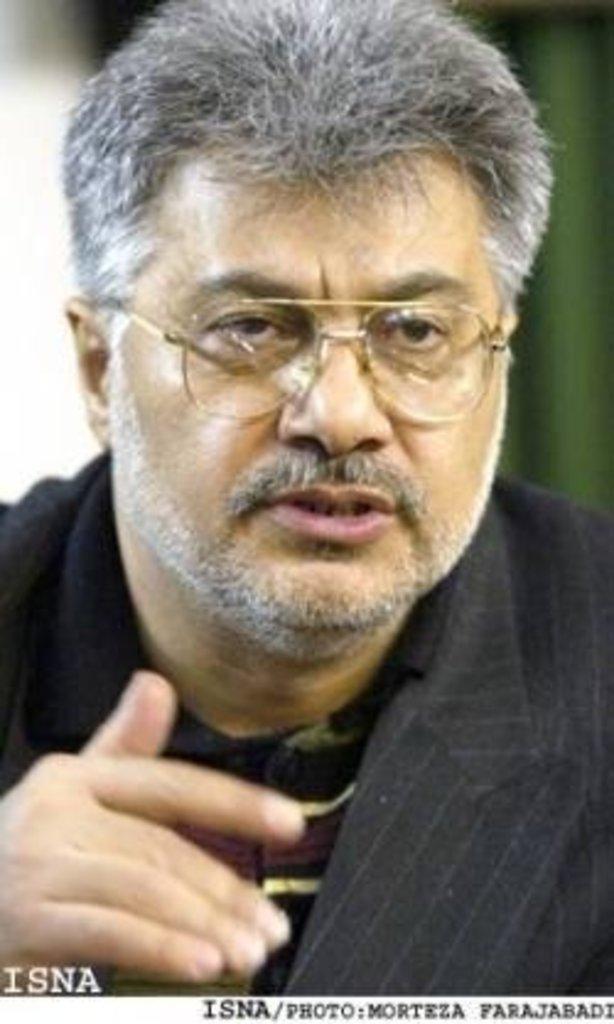Describe this image in one or two sentences. In this picture I see a man in front and I see the watermark on the bottom of this picture. 